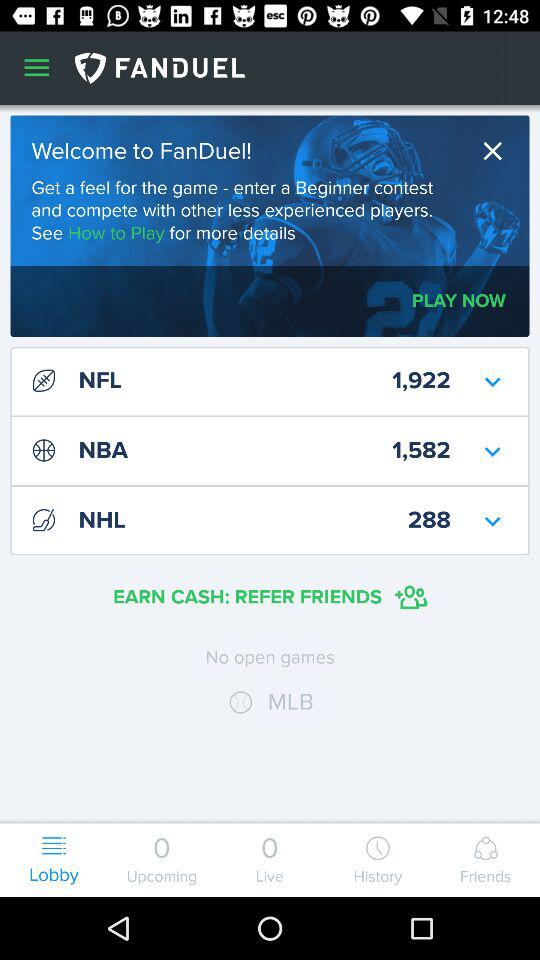How many games are available to play?
Answer the question using a single word or phrase. 3 